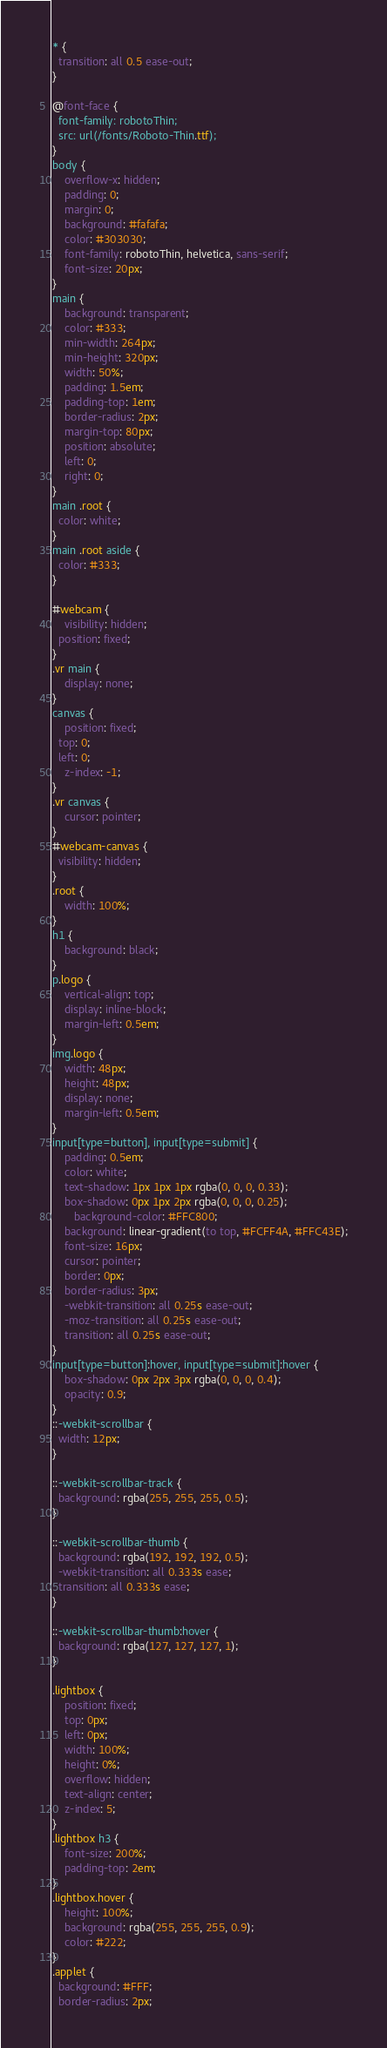Convert code to text. <code><loc_0><loc_0><loc_500><loc_500><_CSS_>* {
  transition: all 0.5 ease-out;
}

@font-face {
  font-family: robotoThin;
  src: url(/fonts/Roboto-Thin.ttf);
}
body {
	overflow-x: hidden;
    padding: 0;
    margin: 0;
    background: #fafafa;
    color: #303030;
    font-family: robotoThin, helvetica, sans-serif;
	font-size: 20px;
}
main {
    background: transparent;
    color: #333;
    min-width: 264px;
    min-height: 320px;
    width: 50%;
    padding: 1.5em;
    padding-top: 1em;
    border-radius: 2px;
    margin-top: 80px;
    position: absolute;
    left: 0;
    right: 0;
}
main .root {
  color: white;
}
main .root aside {
  color: #333;
}

#webcam {
	visibility: hidden;
  position: fixed;
}
.vr main {
	display: none;
}
canvas {
	position: fixed;
  top: 0;
  left: 0;
	z-index: -1;
}
.vr canvas {
	cursor: pointer;
}
#webcam-canvas {
  visibility: hidden;
}
.root {
	width: 100%;
}
h1 {
    background: black;
}
p.logo {
    vertical-align: top;
    display: inline-block;
    margin-left: 0.5em;
}
img.logo {
    width: 48px;
    height: 48px;
    display: none;
    margin-left: 0.5em;
}
input[type=button], input[type=submit] {
    padding: 0.5em;
    color: white;
    text-shadow: 1px 1px 1px rgba(0, 0, 0, 0.33);
    box-shadow: 0px 1px 2px rgba(0, 0, 0, 0.25);
	   background-color: #FFC800;
    background: linear-gradient(to top, #FCFF4A, #FFC43E);
    font-size: 16px;
    cursor: pointer;
    border: 0px;
    border-radius: 3px;
    -webkit-transition: all 0.25s ease-out;
	-moz-transition: all 0.25s ease-out;
	transition: all 0.25s ease-out;
}
input[type=button]:hover, input[type=submit]:hover {
    box-shadow: 0px 2px 3px rgba(0, 0, 0, 0.4);
    opacity: 0.9;
}
::-webkit-scrollbar {
  width: 12px;
}

::-webkit-scrollbar-track {
  background: rgba(255, 255, 255, 0.5);
}

::-webkit-scrollbar-thumb {
  background: rgba(192, 192, 192, 0.5);
  -webkit-transition: all 0.333s ease;
  transition: all 0.333s ease;
}

::-webkit-scrollbar-thumb:hover {
  background: rgba(127, 127, 127, 1);
}

.lightbox {
	position: fixed;
	top: 0px;
	left: 0px;
	width: 100%;
	height: 0%;
	overflow: hidden;
	text-align: center;
    z-index: 5;
}
.lightbox h3 {
	font-size: 200%;
	padding-top: 2em;
}
.lightbox.hover {
	height: 100%;
	background: rgba(255, 255, 255, 0.9);
	color: #222;
}
.applet {
  background: #FFF;
  border-radius: 2px;</code> 